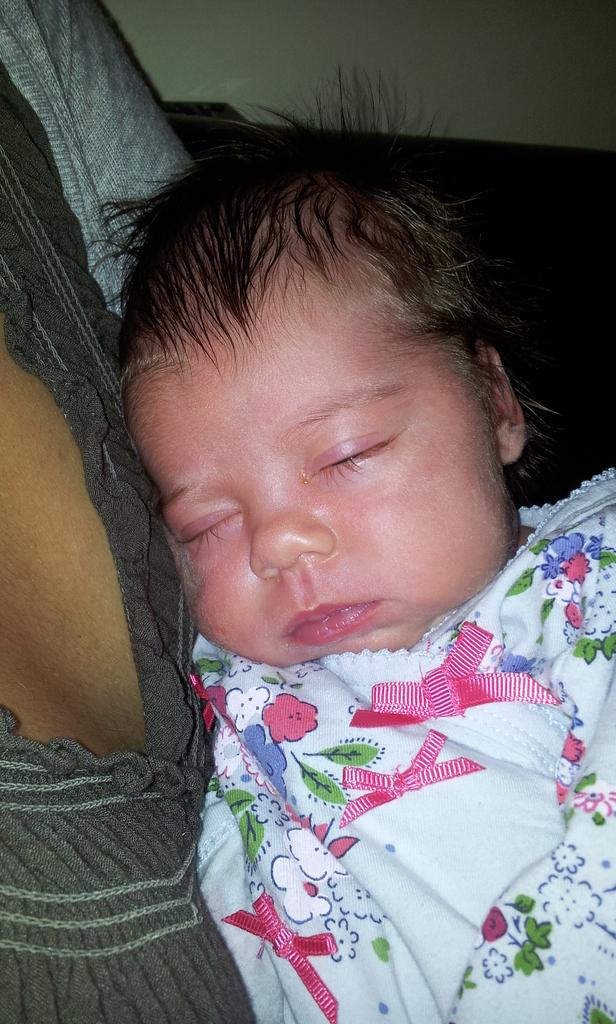What is the main subject of the image? There is a baby in the image. Can you describe the person with the baby? There is a person with dresses in the image. What is the color scheme of the background in the image? The background of the image is white and black. How does the baby compare to the workload of the person in the image? There is no indication of a workload in the image, as it features a baby and a person with dresses. --- Facts: 1. There is a car in the image. 2. The car is red. 3. The car has four wheels. 4. There is a road in the image. 5. The road is paved. Absurd Topics: dance, ocean, animal Conversation: What is the main subject of the image? There is a car in the image. Can you describe the car's appearance? The car is red and has four wheels. What is the surface of the road in the image? The road is paved. Reasoning: Let's think step by step in order to produce the conversation. We start by identifying the main subject of the image, which is the car. Then, we describe the car's appearance, noting its color and the number of wheels. Finally, we describe the road in the image, noting that it is paved. Absurd Question/Answer: Can you see any animals dancing in the ocean in the image? There is no ocean or animals dancing in the image; it features a red car with four wheels and a paved road. 